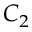Convert formula to latex. <formula><loc_0><loc_0><loc_500><loc_500>C _ { 2 }</formula> 